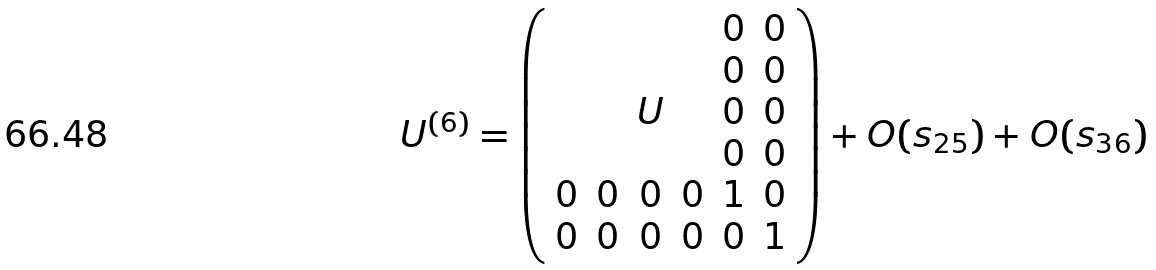<formula> <loc_0><loc_0><loc_500><loc_500>U ^ { ( 6 ) } = \left ( \begin{array} { c c c c c c } \, & \, & \, & \, & 0 & 0 \\ \, & \, & \, & \, & 0 & 0 \\ \, & \, & U & \, & 0 & 0 \\ \, & \, & \, & \, & 0 & 0 \\ 0 & 0 & 0 & 0 & 1 & 0 \\ 0 & 0 & 0 & 0 & 0 & 1 \end{array} \right ) + O ( s _ { 2 5 } ) + O ( s _ { 3 6 } )</formula> 